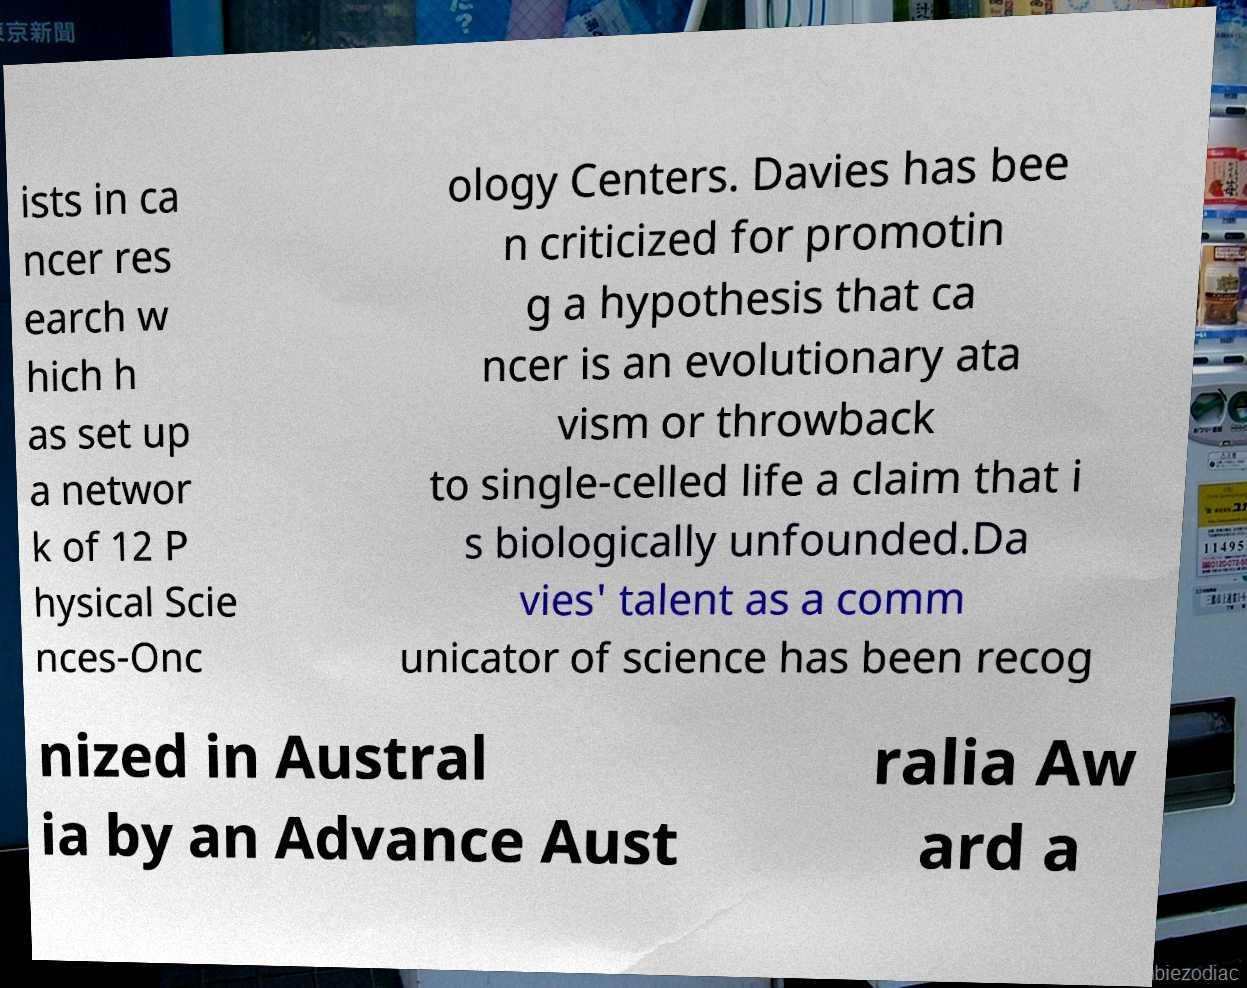Could you assist in decoding the text presented in this image and type it out clearly? ists in ca ncer res earch w hich h as set up a networ k of 12 P hysical Scie nces-Onc ology Centers. Davies has bee n criticized for promotin g a hypothesis that ca ncer is an evolutionary ata vism or throwback to single-celled life a claim that i s biologically unfounded.Da vies' talent as a comm unicator of science has been recog nized in Austral ia by an Advance Aust ralia Aw ard a 